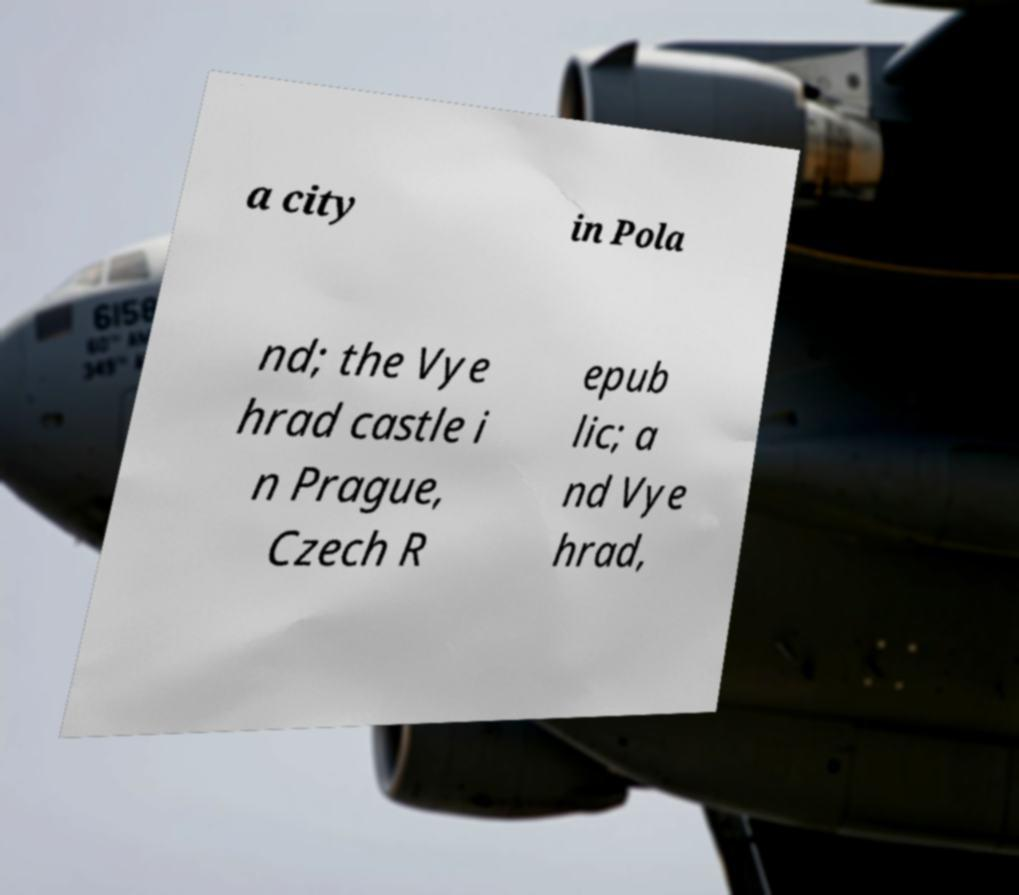Please read and relay the text visible in this image. What does it say? a city in Pola nd; the Vye hrad castle i n Prague, Czech R epub lic; a nd Vye hrad, 